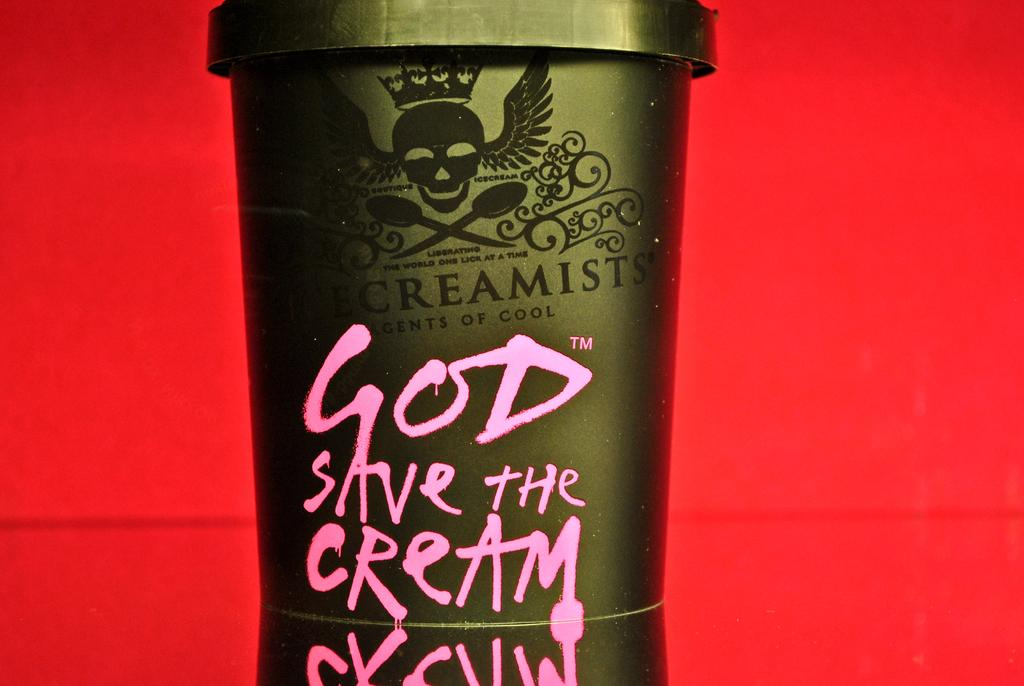<image>
Provide a brief description of the given image. An ice cream container with God save the cream written on it. 